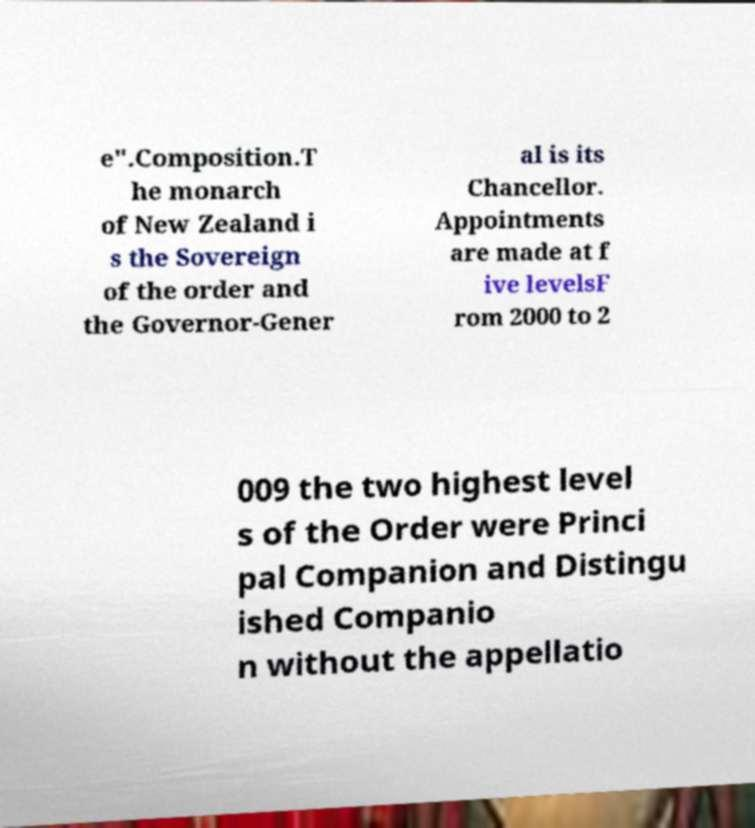Please identify and transcribe the text found in this image. e".Composition.T he monarch of New Zealand i s the Sovereign of the order and the Governor-Gener al is its Chancellor. Appointments are made at f ive levelsF rom 2000 to 2 009 the two highest level s of the Order were Princi pal Companion and Distingu ished Companio n without the appellatio 